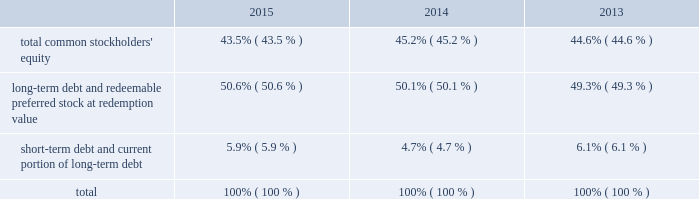The facility is considered 201cdebt 201d for purposes of a support agreement between american water and awcc , which serves as a functional equivalent of a guarantee by american water of awcc 2019s payment obligations under the credit facility .
Also , the company acquired an additional revolving line of credit as part of its keystone acquisition .
The total commitment under this credit facility was $ 16 million of which $ 2 million was outstanding as of december 31 , 2015 .
The table summarizes information regarding the company 2019s aggregate credit facility commitments , letter of credit sub-limits and available funds under those revolving credit facilities , as well as outstanding amounts of commercial paper and outstanding borrowings under the respective facilities as of december 31 , 2015 and 2014 : credit facility commitment available credit facility capacity letter of credit sublimit available letter of credit capacity outstanding commercial ( net of discount ) credit line borrowing ( in millions ) december 31 , 2015 .
$ 1266 $ 1182 $ 150 $ 68 $ 626 $ 2 december 31 , 2014 .
$ 1250 $ 1212 $ 150 $ 112 $ 450 $ 2014 the weighted-average interest rate on awcc short-term borrowings for the years ended december 31 , 2015 and 2014 was approximately 0.49% ( 0.49 % ) and 0.31% ( 0.31 % ) , respectively .
Interest accrues on the keystone revolving line of credit daily at a rate per annum equal to 2.75% ( 2.75 % ) above the greater of the one month or one day libor .
Capital structure the table indicates the percentage of our capitalization represented by the components of our capital structure as of december 31: .
The changes in the capital structure between periods were mainly attributable to changes in outstanding commercial paper balances .
Debt covenants our debt agreements contain financial and non-financial covenants .
To the extent that we are not in compliance with these covenants such an event may create an event of default under the debt agreement and we or our subsidiaries may be restricted in our ability to pay dividends , issue new debt or access our revolving credit facility .
For two of our smaller operating companies , we have informed our counterparties that we will provide only unaudited financial information at the subsidiary level , which resulted in technical non-compliance with certain of their reporting requirements under debt agreements with respect to $ 8 million of outstanding debt .
We do not believe this event will materially impact us .
Our long-term debt indentures contain a number of covenants that , among other things , limit the company from issuing debt secured by the company 2019s assets , subject to certain exceptions .
Our failure to comply with any of these covenants could accelerate repayment obligations .
Certain long-term notes and the revolving credit facility require us to maintain a ratio of consolidated debt to consolidated capitalization ( as defined in the relevant documents ) of not more than 0.70 to 1.00 .
On december 31 , 2015 , our ratio was 0.56 to 1.00 and therefore we were in compliance with the covenant. .
What was the ratio of the commercial ( net of discount ) credit line borrowing from 2015 to 2014? 
Rationale: for every dollar of commercial ( net of discount ) credit line borrowing in 2014 , there was 1.39 in 2015
Computations: (626 / 450)
Answer: 1.39111. The facility is considered 201cdebt 201d for purposes of a support agreement between american water and awcc , which serves as a functional equivalent of a guarantee by american water of awcc 2019s payment obligations under the credit facility .
Also , the company acquired an additional revolving line of credit as part of its keystone acquisition .
The total commitment under this credit facility was $ 16 million of which $ 2 million was outstanding as of december 31 , 2015 .
The table summarizes information regarding the company 2019s aggregate credit facility commitments , letter of credit sub-limits and available funds under those revolving credit facilities , as well as outstanding amounts of commercial paper and outstanding borrowings under the respective facilities as of december 31 , 2015 and 2014 : credit facility commitment available credit facility capacity letter of credit sublimit available letter of credit capacity outstanding commercial ( net of discount ) credit line borrowing ( in millions ) december 31 , 2015 .
$ 1266 $ 1182 $ 150 $ 68 $ 626 $ 2 december 31 , 2014 .
$ 1250 $ 1212 $ 150 $ 112 $ 450 $ 2014 the weighted-average interest rate on awcc short-term borrowings for the years ended december 31 , 2015 and 2014 was approximately 0.49% ( 0.49 % ) and 0.31% ( 0.31 % ) , respectively .
Interest accrues on the keystone revolving line of credit daily at a rate per annum equal to 2.75% ( 2.75 % ) above the greater of the one month or one day libor .
Capital structure the table indicates the percentage of our capitalization represented by the components of our capital structure as of december 31: .
The changes in the capital structure between periods were mainly attributable to changes in outstanding commercial paper balances .
Debt covenants our debt agreements contain financial and non-financial covenants .
To the extent that we are not in compliance with these covenants such an event may create an event of default under the debt agreement and we or our subsidiaries may be restricted in our ability to pay dividends , issue new debt or access our revolving credit facility .
For two of our smaller operating companies , we have informed our counterparties that we will provide only unaudited financial information at the subsidiary level , which resulted in technical non-compliance with certain of their reporting requirements under debt agreements with respect to $ 8 million of outstanding debt .
We do not believe this event will materially impact us .
Our long-term debt indentures contain a number of covenants that , among other things , limit the company from issuing debt secured by the company 2019s assets , subject to certain exceptions .
Our failure to comply with any of these covenants could accelerate repayment obligations .
Certain long-term notes and the revolving credit facility require us to maintain a ratio of consolidated debt to consolidated capitalization ( as defined in the relevant documents ) of not more than 0.70 to 1.00 .
On december 31 , 2015 , our ratio was 0.56 to 1.00 and therefore we were in compliance with the covenant. .
By how much did the long-term debt and redeemable preferred stock at redemption value portion of the company's capital structure increase from 2013 to 2015? 
Computations: (50.6% - 49.3%)
Answer: 0.013. 